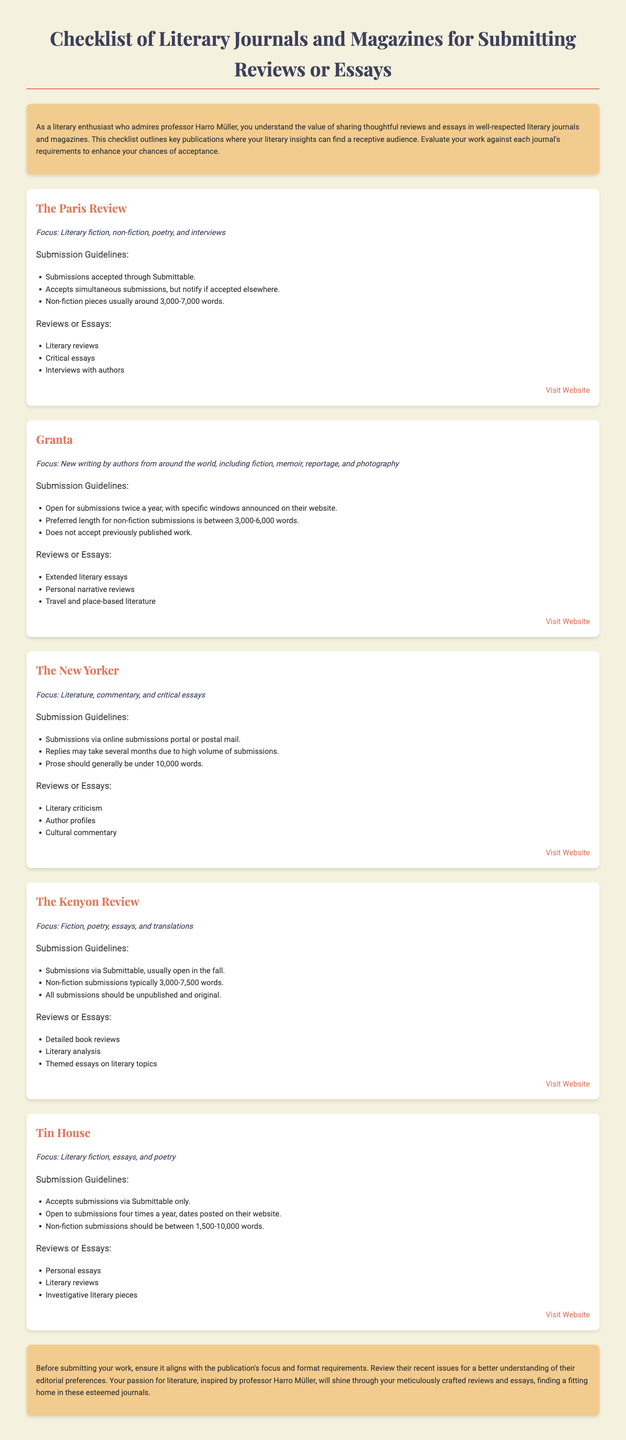What is the focus of The Paris Review? The focus of The Paris Review includes literary fiction, non-fiction, poetry, and interviews as stated in the document.
Answer: Literary fiction, non-fiction, poetry, and interviews How many words are suggested for non-fiction pieces for The New Yorker? The New Yorker mentions that prose should generally be under 10,000 words according to the submission guidelines.
Answer: 10,000 words How often does Granta accept submissions? The document indicates that Granta is open for submissions twice a year, with specific windows announced on their website.
Answer: Twice a year What is the primary submission method for Tin House? Tin House specifies that submissions are accepted via Submittable only as mentioned in the guidelines.
Answer: Submittable only What type of essays does The Kenyon Review accept? The Kenyon Review accepts detailed book reviews, literary analysis, and themed essays on literary topics as stated in the document.
Answer: Detailed book reviews, literary analysis, themed essays What is the maximum word count for non-fiction submissions to Granta? Granta's preferred length for non-fiction submissions is between 3,000-6,000 words, as stated in the guidelines.
Answer: 6,000 words What should you ensure before submitting your work? The document advises ensuring that your work aligns with the publication's focus and format requirements before submission.
Answer: Aligns with publication's focus and format requirements What is the primary focus of The Kenyon Review? The focus of The Kenyon Review includes fiction, poetry, essays, and translations, as stated in the document.
Answer: Fiction, poetry, essays, and translations 